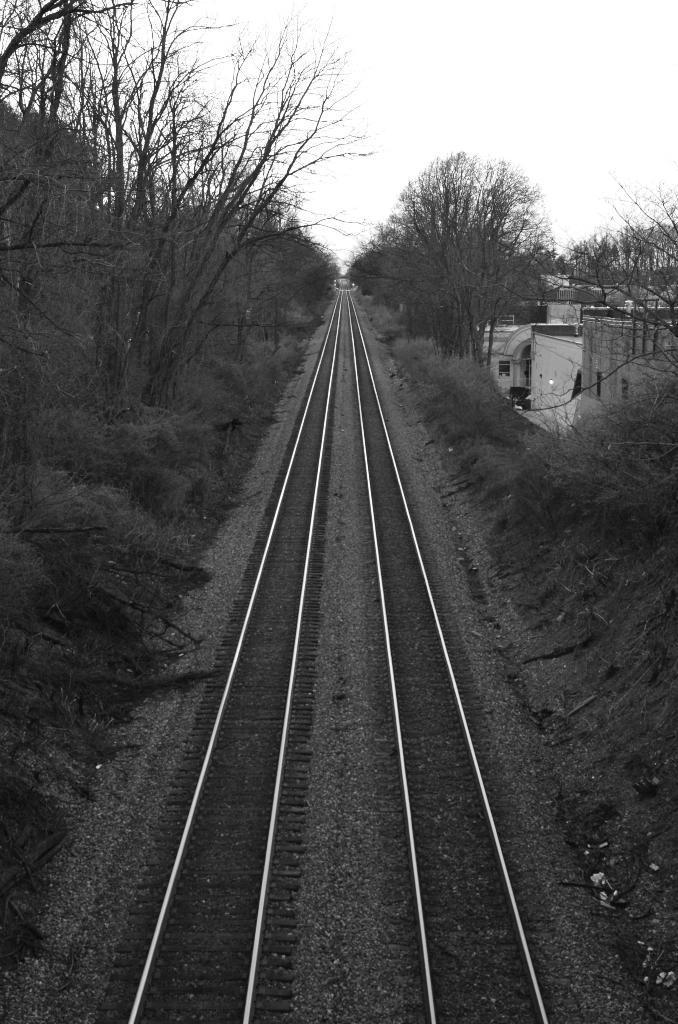Could you give a brief overview of what you see in this image? In this picture, we can see rail tracks, ground with grass, plants, trees, houses, and the sky. 